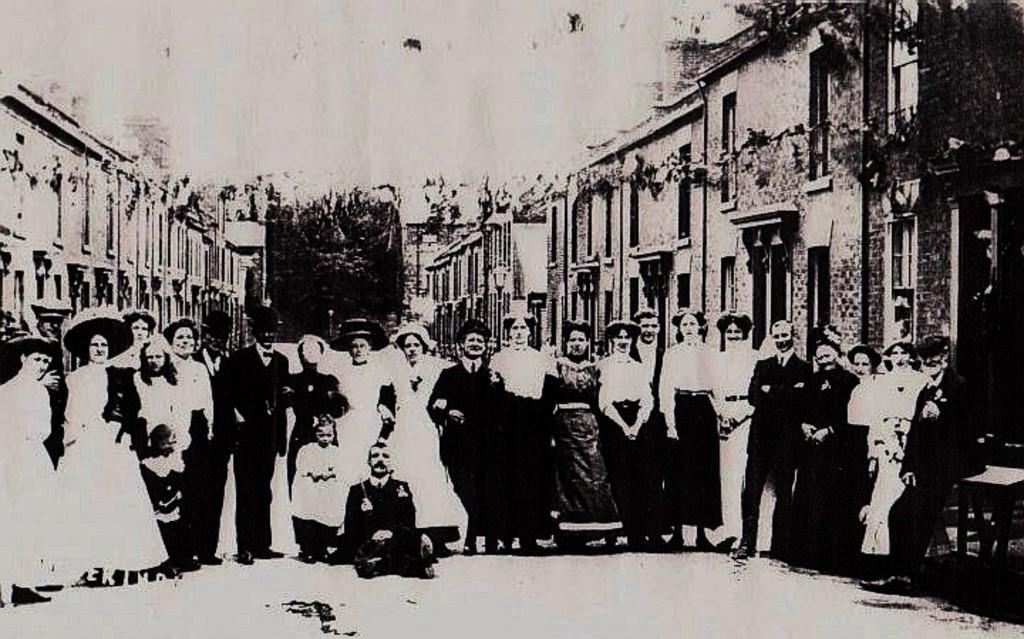What is the color scheme of the image? The image is black and white. How old might the image be? The image is old. What can be seen in the foreground of the image? There is a group of people standing in the foreground. What are the people in the image doing? The people are posing for a photo. What can be seen in the background of the image? There are buildings visible in the background. Can you see any fish swimming in the water in the image? There is no water or fish present in the image. What type of soda is being served at the event in the image? There is no event or soda present in the image; it features a group of people posing for a photo in front of buildings. 